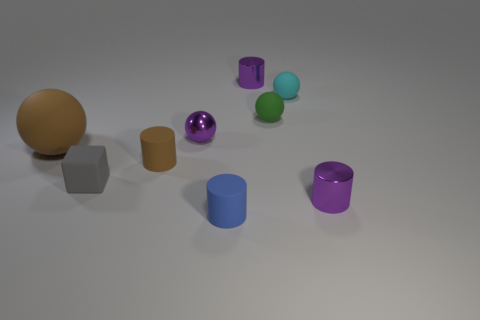Are there any other things that have the same size as the brown matte sphere?
Keep it short and to the point. No. Is the small blue object made of the same material as the purple ball?
Offer a terse response. No. How many objects are cylinders that are behind the big brown ball or objects that are behind the gray matte object?
Make the answer very short. 6. Is there a cyan matte sphere of the same size as the blue object?
Offer a terse response. Yes. What is the color of the small metallic thing that is the same shape as the big object?
Offer a very short reply. Purple. Is there a small purple shiny cylinder in front of the rubber sphere that is on the left side of the blue matte object?
Ensure brevity in your answer.  Yes. Does the small purple object that is behind the small cyan rubber thing have the same shape as the tiny gray thing?
Your response must be concise. No. What shape is the gray object?
Your answer should be very brief. Cube. How many green balls have the same material as the blue object?
Offer a very short reply. 1. There is a large thing; is it the same color as the matte cylinder that is behind the rubber block?
Your answer should be very brief. Yes. 